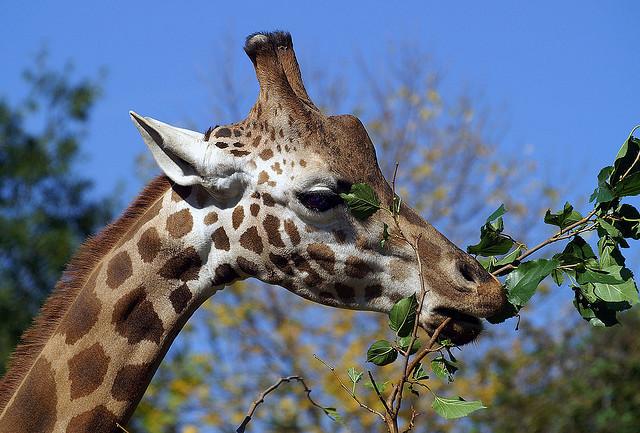Do the horns form a U?
Concise answer only. Yes. What position are the ears?
Keep it brief. Back. What number of spots are on the giraffe?
Be succinct. 40. Is it raining in this picture?
Quick response, please. No. Is the giraffe facing the right side?
Keep it brief. Yes. What is the giraffe eating?
Concise answer only. Leaves. Is the giraffe trying to eat the whole plant?
Write a very short answer. Yes. 